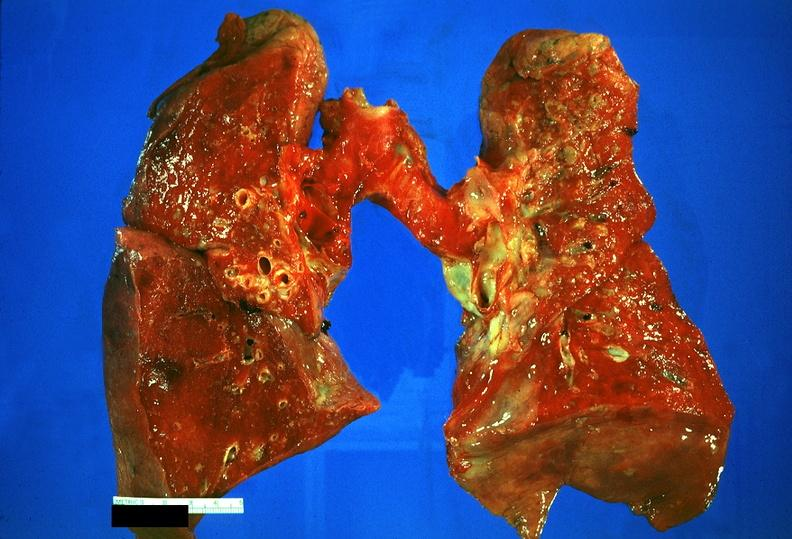s the excellent uterus present?
Answer the question using a single word or phrase. No 